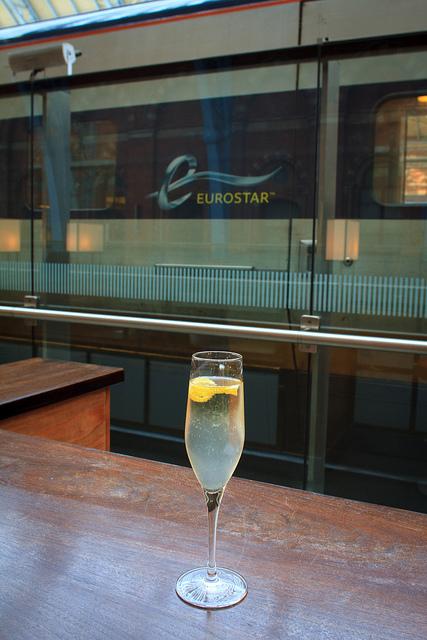How many glasses are there?
Quick response, please. 1. What kind of drink is this?
Keep it brief. Champagne. What is the name on the train?
Short answer required. Eurostar. 